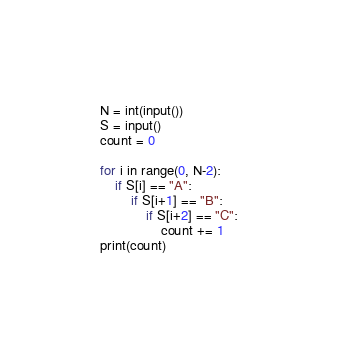<code> <loc_0><loc_0><loc_500><loc_500><_Python_>N = int(input())
S = input()
count = 0

for i in range(0, N-2):
    if S[i] == "A":
        if S[i+1] == "B":
            if S[i+2] == "C":
                count += 1
print(count)</code> 